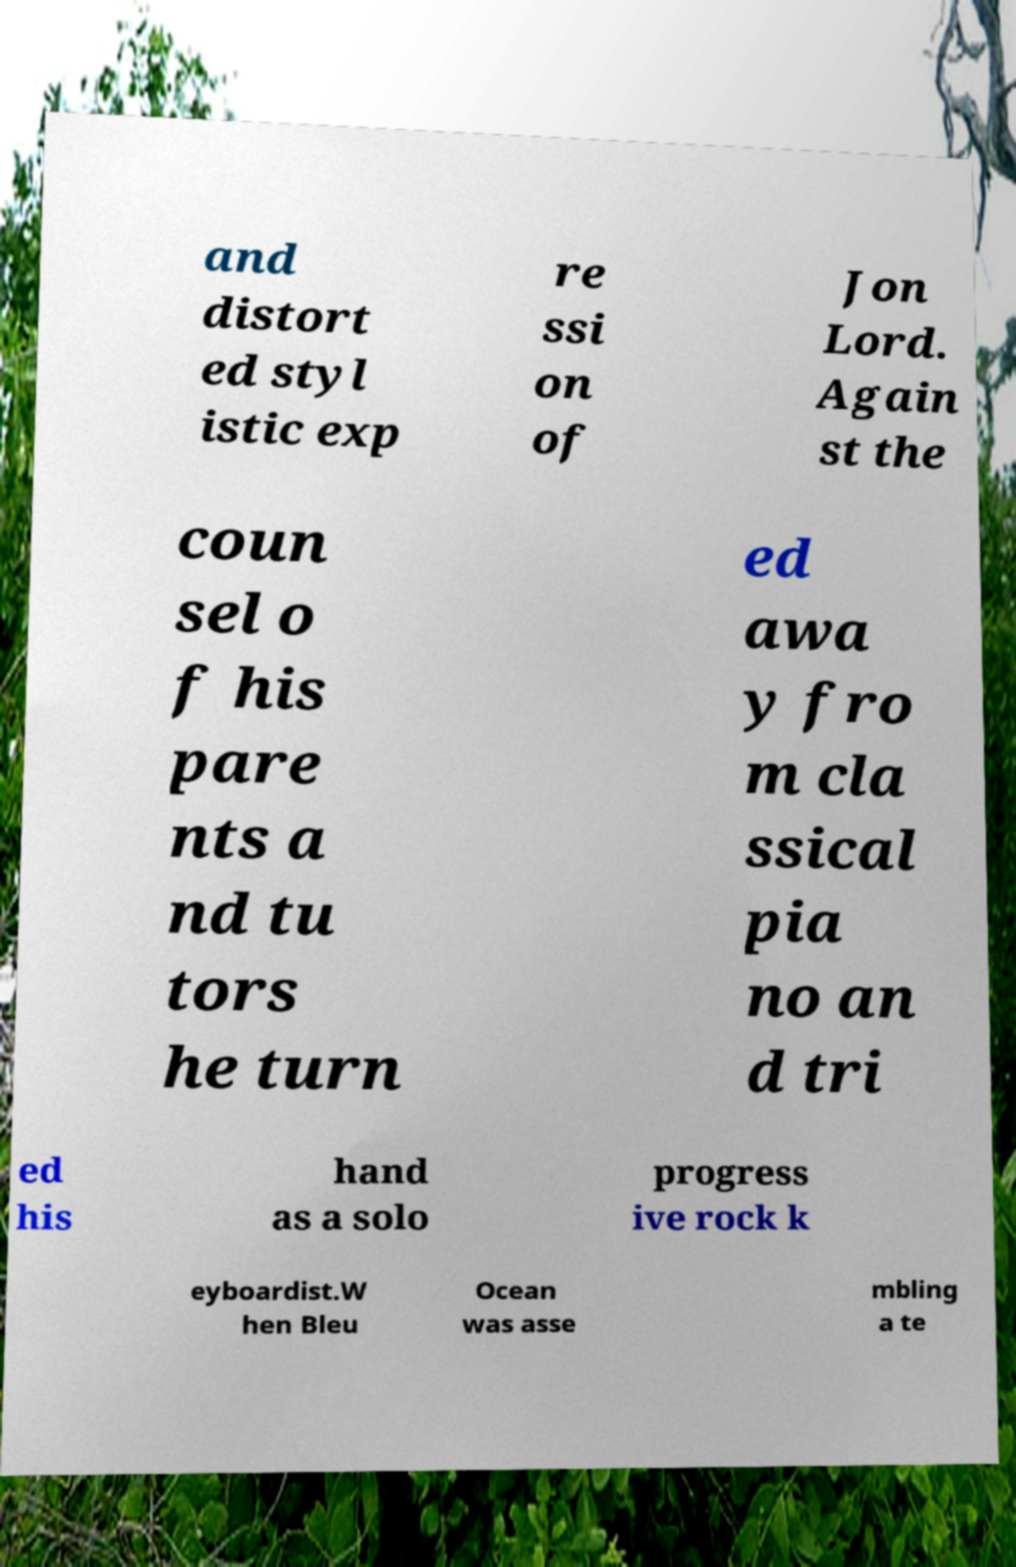Could you extract and type out the text from this image? and distort ed styl istic exp re ssi on of Jon Lord. Again st the coun sel o f his pare nts a nd tu tors he turn ed awa y fro m cla ssical pia no an d tri ed his hand as a solo progress ive rock k eyboardist.W hen Bleu Ocean was asse mbling a te 